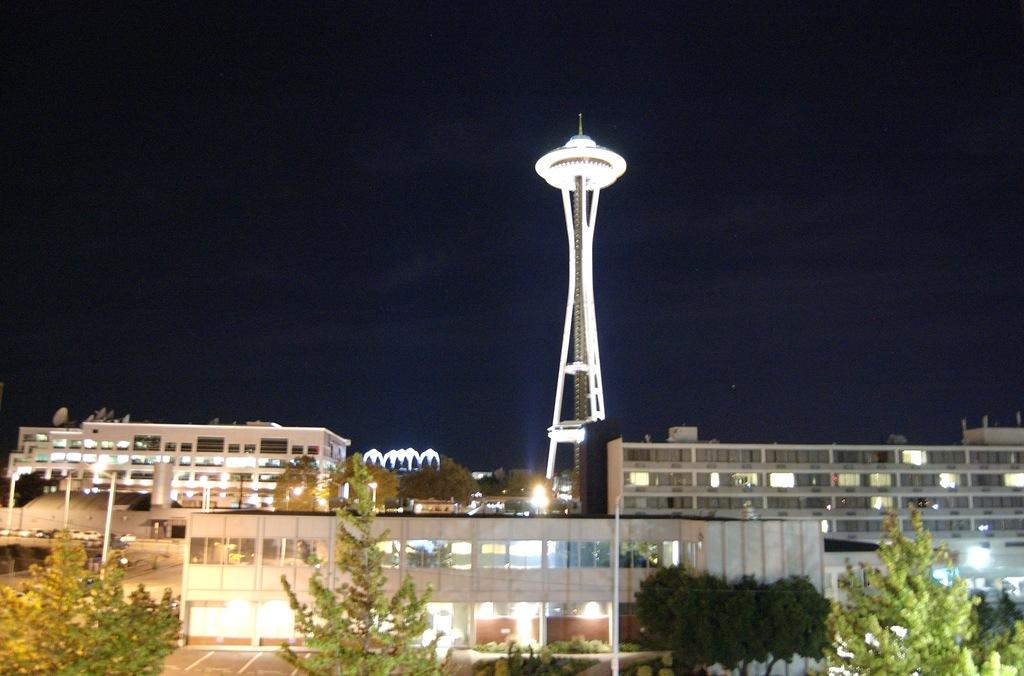What type of structures are present in the image? There are buildings in the image. Can you describe the prominent feature in the center of the image? There is a tower in the center of the image. What type of vegetation can be seen in the image? There are trees visible in the image. What is visible in the background of the image? The sky is visible in the background of the image. What type of furniture can be seen in the image? There is no furniture present in the image; it features buildings, a tower, trees, and the sky. How much milk is being poured from the tower in the image? There is no milk or pouring action depicted in the image; it shows a tower, buildings, trees, and the sky. 